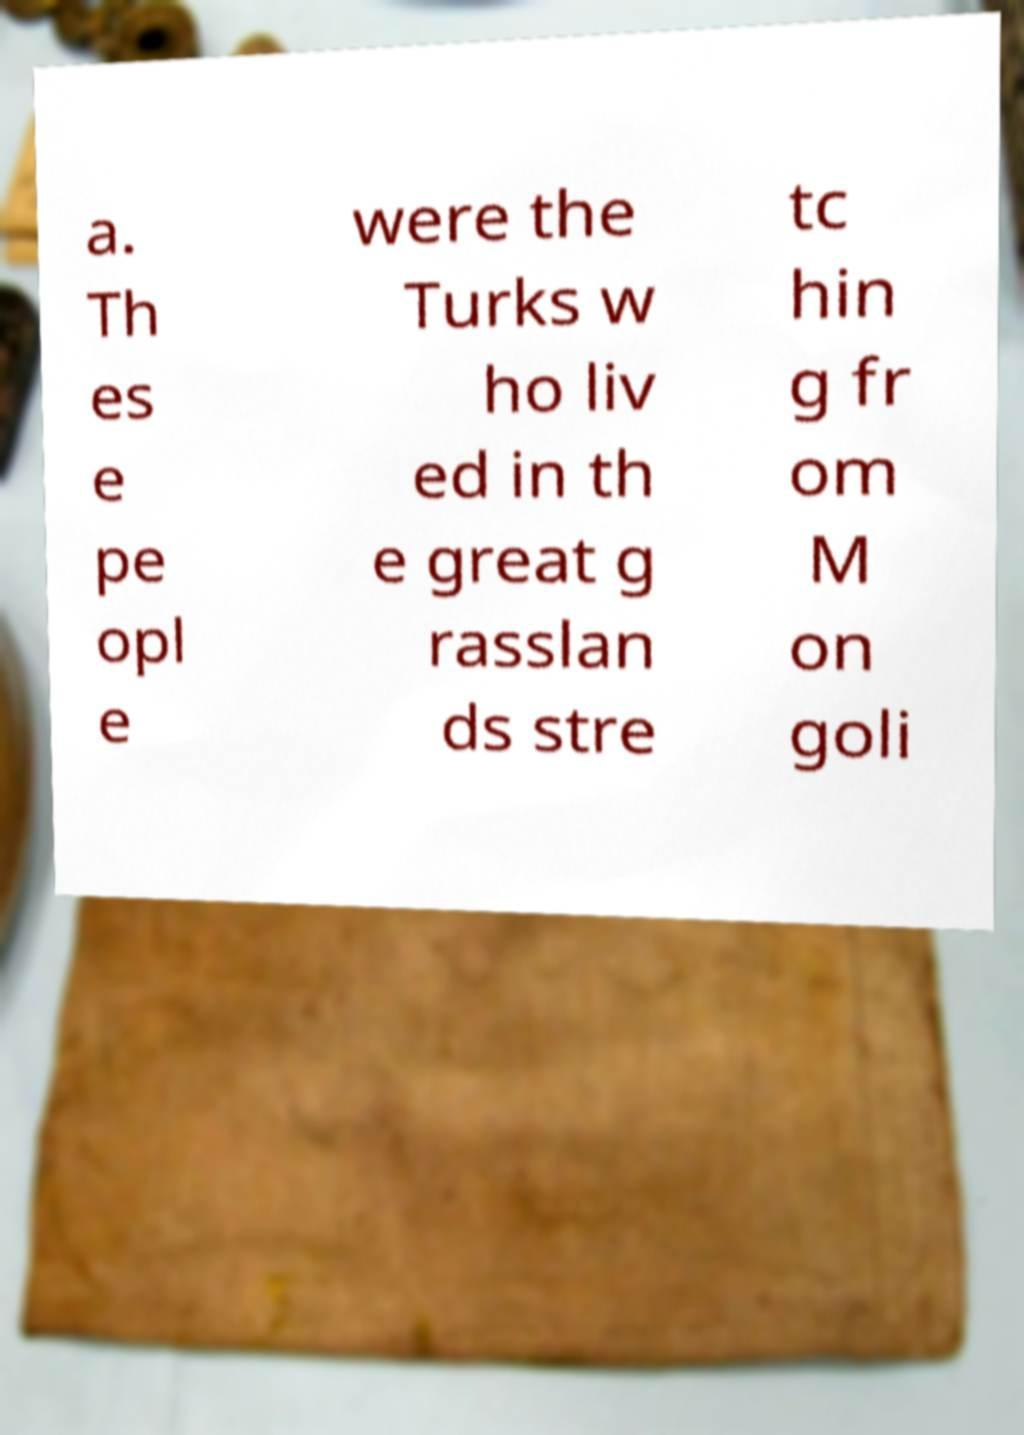Can you accurately transcribe the text from the provided image for me? a. Th es e pe opl e were the Turks w ho liv ed in th e great g rasslan ds stre tc hin g fr om M on goli 